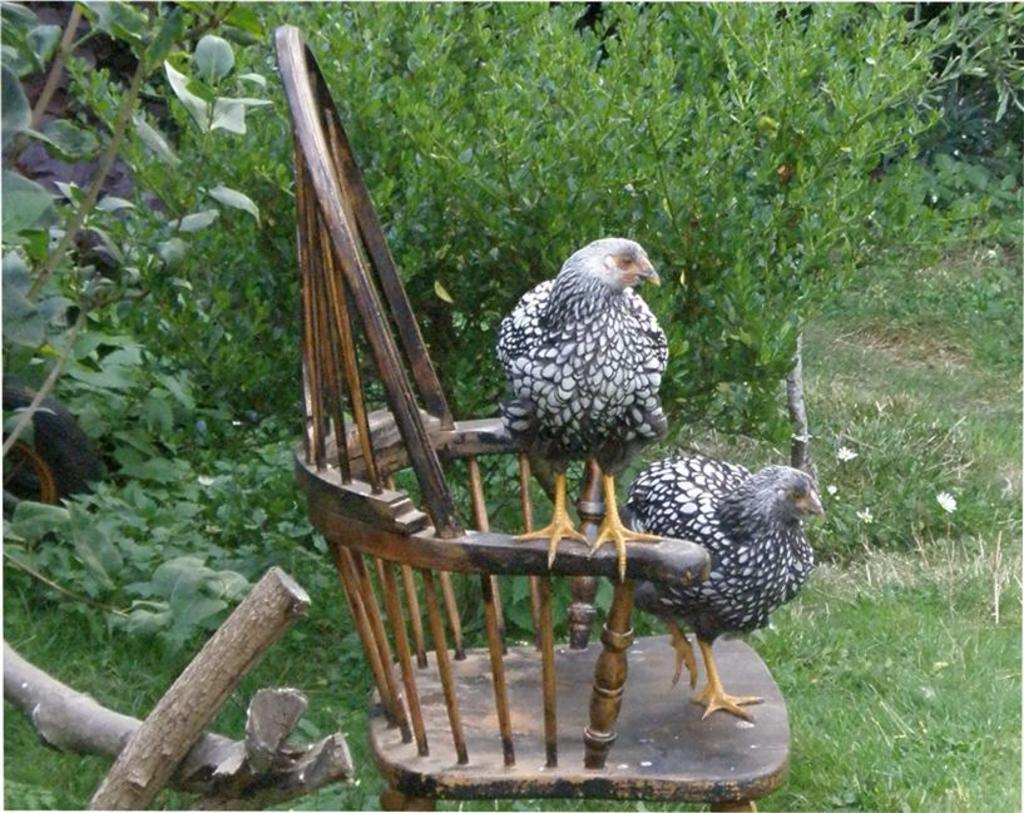How many hens are in the image? There are two hens in the image. What are the hens doing in the image? The hens are standing on a chair. What can be seen around the chair in the image? There are plants around the chair. What type of ground surface is visible in the image? There is grass visible in the image. Can you see a faucet in the image? No, there is no faucet present in the image. 